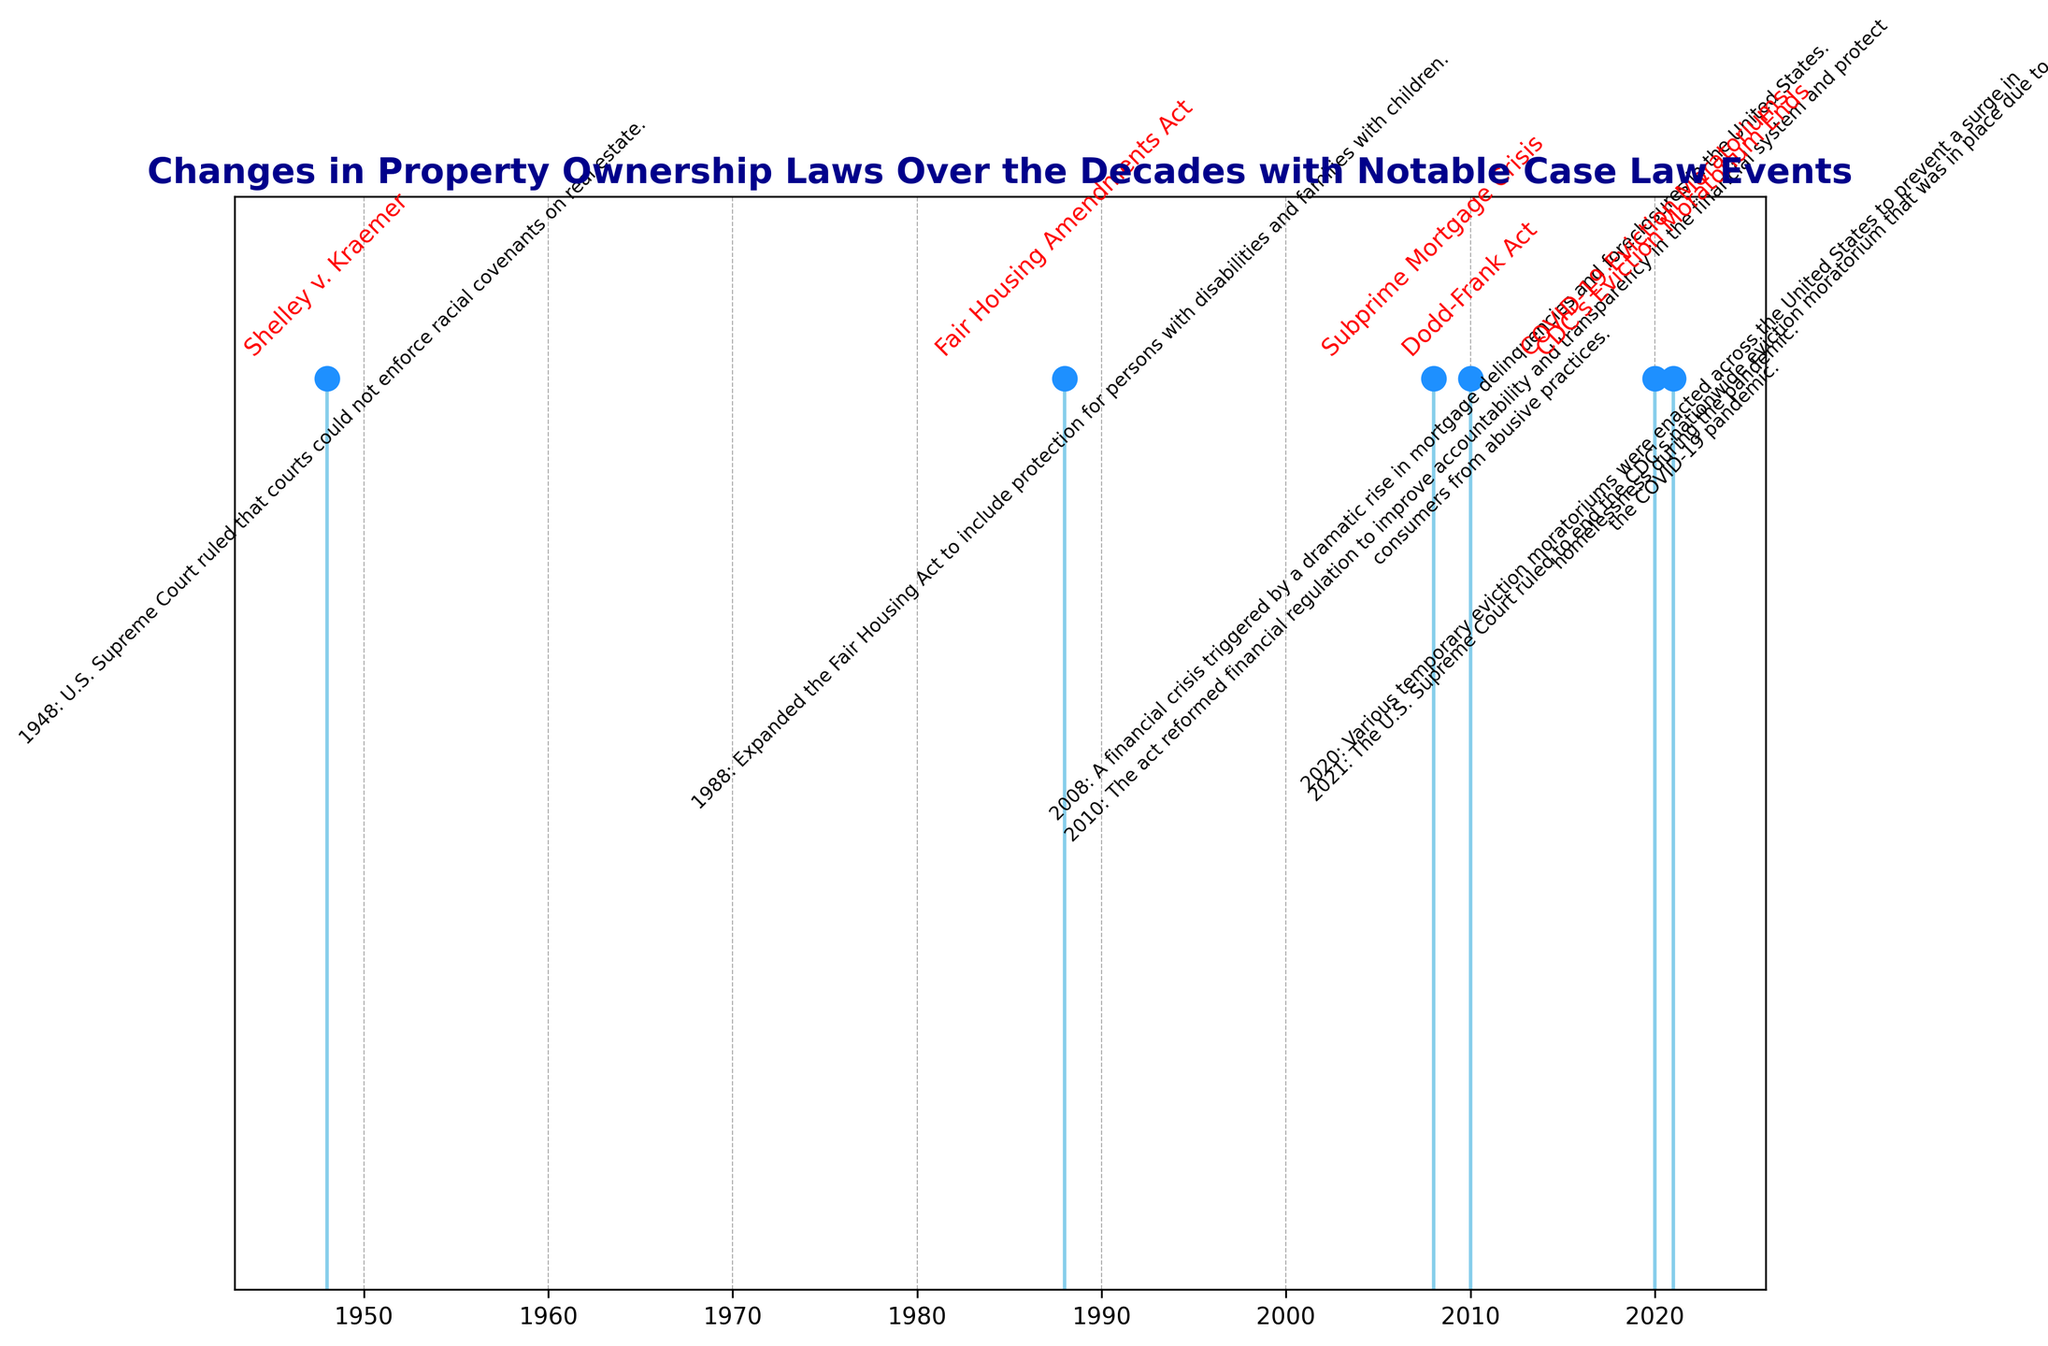Which event occurred first according to the plot? The plot shows years along the x-axis with vertical lines indicating events. The first event is at the leftmost point of the x-axis. By locating the leftmost point, we see the year 1948 with "Shelley v. Kraemer."
Answer: Shelley v. Kraemer What is the difference in years between the "Subprime Mortgage Crisis" and the "Dodd-Frank Act"? To find the difference, we subtract the year of the "Subprime Mortgage Crisis" (2008) from the year of the "Dodd-Frank Act" (2010). 2010 - 2008 equals 2 years.
Answer: 2 years Which event related to eviction moratoriums happened first? There are two events related to eviction moratoriums. The plot shows "COVID-19 Eviction Moratoriums" in 2020 and "CDC's Eviction Moratorium Ends" in 2021. 2020 comes before 2021.
Answer: COVID-19 Eviction Moratoriums How many years are between "Shelley v. Kraemer" and the "Fair Housing Amendments Act"? Subtract the year of "Shelley v. Kraemer" (1948) from the year of the "Fair Housing Amendments Act" (1988). This means 1988 - 1948 = 40 years.
Answer: 40 years Which event has a red annotation text besides its year and description? The visual attribute of the plot shows that the event names are annotated in red text. By looking visually at the annotations, all events have red text.
Answer: All events During which decade did the "Subprime Mortgage Crisis" occur? Locate the year of the "Subprime Mortgage Crisis" in the plot, which is 2008. Decades group years in sets of tens. Therefore, 2008 occurs in the 2000s.
Answer: 2000s Compare the years of "Dodd-Frank Act" and "CDC's Eviction Moratorium Ends". Which one came later? Find the years of both events from the plot: "Dodd-Frank Act" is in 2010 and "CDC's Eviction Moratorium Ends" is in 2021. Since 2021 is greater than 2010, "CDC's Eviction Moratorium Ends" occurred later.
Answer: CDC's Eviction Moratorium Ends What is the range of years covered by the events in the plot? To find the range, subtract the earliest year (1948) from the latest year (2021). 2021 - 1948 = 73 years.
Answer: 73 years Which event is associated with the year 1988? Check the plot to see which event is aligned with the year 1988. The event listed next to 1988 is the "Fair Housing Amendments Act."
Answer: Fair Housing Amendments Act 